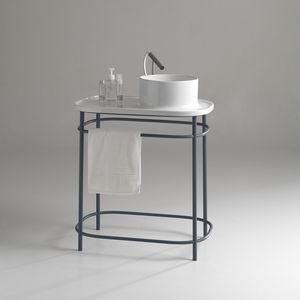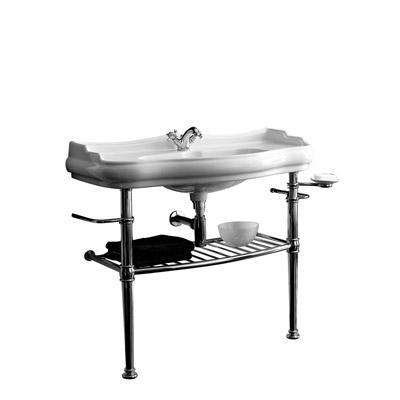The first image is the image on the left, the second image is the image on the right. Considering the images on both sides, is "One sink is round shaped." valid? Answer yes or no. Yes. The first image is the image on the left, the second image is the image on the right. For the images displayed, is the sentence "One image shows a rectangular sink supported by two metal legs, with a horizontal bar along three sides." factually correct? Answer yes or no. No. 